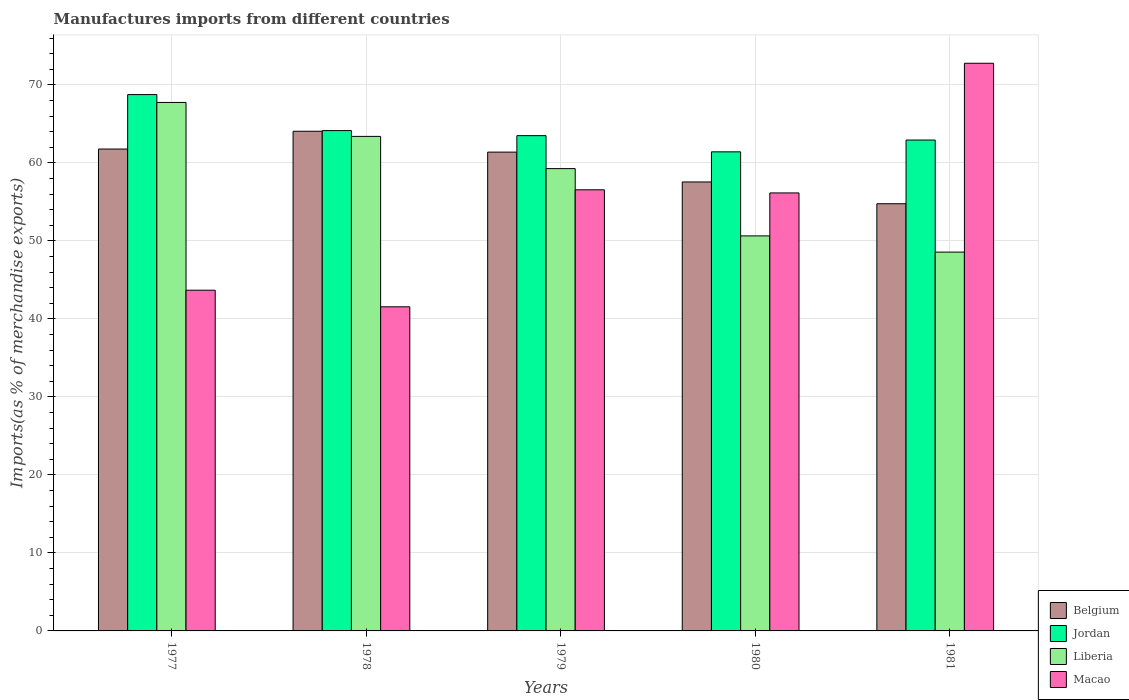How many different coloured bars are there?
Your answer should be very brief. 4. Are the number of bars per tick equal to the number of legend labels?
Your response must be concise. Yes. How many bars are there on the 4th tick from the left?
Your answer should be very brief. 4. What is the label of the 1st group of bars from the left?
Your answer should be very brief. 1977. In how many cases, is the number of bars for a given year not equal to the number of legend labels?
Offer a terse response. 0. What is the percentage of imports to different countries in Belgium in 1979?
Your answer should be compact. 61.39. Across all years, what is the maximum percentage of imports to different countries in Liberia?
Keep it short and to the point. 67.76. Across all years, what is the minimum percentage of imports to different countries in Belgium?
Give a very brief answer. 54.77. In which year was the percentage of imports to different countries in Belgium maximum?
Your answer should be very brief. 1978. In which year was the percentage of imports to different countries in Liberia minimum?
Ensure brevity in your answer.  1981. What is the total percentage of imports to different countries in Belgium in the graph?
Provide a succinct answer. 299.56. What is the difference between the percentage of imports to different countries in Belgium in 1977 and that in 1980?
Your response must be concise. 4.22. What is the difference between the percentage of imports to different countries in Liberia in 1981 and the percentage of imports to different countries in Jordan in 1978?
Give a very brief answer. -15.58. What is the average percentage of imports to different countries in Liberia per year?
Ensure brevity in your answer.  57.93. In the year 1978, what is the difference between the percentage of imports to different countries in Macao and percentage of imports to different countries in Belgium?
Give a very brief answer. -22.51. In how many years, is the percentage of imports to different countries in Jordan greater than 28 %?
Give a very brief answer. 5. What is the ratio of the percentage of imports to different countries in Macao in 1979 to that in 1980?
Your response must be concise. 1.01. Is the percentage of imports to different countries in Jordan in 1979 less than that in 1981?
Give a very brief answer. No. Is the difference between the percentage of imports to different countries in Macao in 1980 and 1981 greater than the difference between the percentage of imports to different countries in Belgium in 1980 and 1981?
Offer a very short reply. No. What is the difference between the highest and the second highest percentage of imports to different countries in Liberia?
Offer a very short reply. 4.35. What is the difference between the highest and the lowest percentage of imports to different countries in Belgium?
Give a very brief answer. 9.29. What does the 4th bar from the left in 1981 represents?
Your response must be concise. Macao. What does the 1st bar from the right in 1980 represents?
Provide a short and direct response. Macao. Is it the case that in every year, the sum of the percentage of imports to different countries in Macao and percentage of imports to different countries in Jordan is greater than the percentage of imports to different countries in Belgium?
Offer a very short reply. Yes. Are all the bars in the graph horizontal?
Provide a succinct answer. No. Does the graph contain grids?
Ensure brevity in your answer.  Yes. Where does the legend appear in the graph?
Offer a very short reply. Bottom right. How many legend labels are there?
Make the answer very short. 4. What is the title of the graph?
Ensure brevity in your answer.  Manufactures imports from different countries. What is the label or title of the Y-axis?
Give a very brief answer. Imports(as % of merchandise exports). What is the Imports(as % of merchandise exports) of Belgium in 1977?
Keep it short and to the point. 61.78. What is the Imports(as % of merchandise exports) of Jordan in 1977?
Provide a short and direct response. 68.76. What is the Imports(as % of merchandise exports) in Liberia in 1977?
Provide a succinct answer. 67.76. What is the Imports(as % of merchandise exports) of Macao in 1977?
Offer a very short reply. 43.68. What is the Imports(as % of merchandise exports) of Belgium in 1978?
Give a very brief answer. 64.06. What is the Imports(as % of merchandise exports) in Jordan in 1978?
Your answer should be compact. 64.15. What is the Imports(as % of merchandise exports) in Liberia in 1978?
Give a very brief answer. 63.4. What is the Imports(as % of merchandise exports) of Macao in 1978?
Make the answer very short. 41.56. What is the Imports(as % of merchandise exports) of Belgium in 1979?
Your answer should be compact. 61.39. What is the Imports(as % of merchandise exports) of Jordan in 1979?
Offer a very short reply. 63.5. What is the Imports(as % of merchandise exports) of Liberia in 1979?
Provide a short and direct response. 59.27. What is the Imports(as % of merchandise exports) of Macao in 1979?
Offer a very short reply. 56.56. What is the Imports(as % of merchandise exports) in Belgium in 1980?
Keep it short and to the point. 57.56. What is the Imports(as % of merchandise exports) of Jordan in 1980?
Ensure brevity in your answer.  61.42. What is the Imports(as % of merchandise exports) in Liberia in 1980?
Give a very brief answer. 50.65. What is the Imports(as % of merchandise exports) of Macao in 1980?
Your answer should be compact. 56.16. What is the Imports(as % of merchandise exports) of Belgium in 1981?
Ensure brevity in your answer.  54.77. What is the Imports(as % of merchandise exports) of Jordan in 1981?
Keep it short and to the point. 62.94. What is the Imports(as % of merchandise exports) in Liberia in 1981?
Provide a succinct answer. 48.57. What is the Imports(as % of merchandise exports) of Macao in 1981?
Provide a short and direct response. 72.78. Across all years, what is the maximum Imports(as % of merchandise exports) in Belgium?
Your answer should be very brief. 64.06. Across all years, what is the maximum Imports(as % of merchandise exports) in Jordan?
Your answer should be compact. 68.76. Across all years, what is the maximum Imports(as % of merchandise exports) of Liberia?
Offer a very short reply. 67.76. Across all years, what is the maximum Imports(as % of merchandise exports) in Macao?
Make the answer very short. 72.78. Across all years, what is the minimum Imports(as % of merchandise exports) in Belgium?
Your response must be concise. 54.77. Across all years, what is the minimum Imports(as % of merchandise exports) of Jordan?
Provide a succinct answer. 61.42. Across all years, what is the minimum Imports(as % of merchandise exports) of Liberia?
Keep it short and to the point. 48.57. Across all years, what is the minimum Imports(as % of merchandise exports) of Macao?
Your answer should be very brief. 41.56. What is the total Imports(as % of merchandise exports) of Belgium in the graph?
Keep it short and to the point. 299.56. What is the total Imports(as % of merchandise exports) of Jordan in the graph?
Offer a very short reply. 320.77. What is the total Imports(as % of merchandise exports) in Liberia in the graph?
Offer a very short reply. 289.64. What is the total Imports(as % of merchandise exports) of Macao in the graph?
Provide a short and direct response. 270.73. What is the difference between the Imports(as % of merchandise exports) of Belgium in 1977 and that in 1978?
Your answer should be compact. -2.28. What is the difference between the Imports(as % of merchandise exports) of Jordan in 1977 and that in 1978?
Offer a terse response. 4.62. What is the difference between the Imports(as % of merchandise exports) of Liberia in 1977 and that in 1978?
Make the answer very short. 4.35. What is the difference between the Imports(as % of merchandise exports) of Macao in 1977 and that in 1978?
Your answer should be very brief. 2.13. What is the difference between the Imports(as % of merchandise exports) in Belgium in 1977 and that in 1979?
Keep it short and to the point. 0.4. What is the difference between the Imports(as % of merchandise exports) of Jordan in 1977 and that in 1979?
Your answer should be compact. 5.26. What is the difference between the Imports(as % of merchandise exports) of Liberia in 1977 and that in 1979?
Your answer should be very brief. 8.48. What is the difference between the Imports(as % of merchandise exports) in Macao in 1977 and that in 1979?
Keep it short and to the point. -12.87. What is the difference between the Imports(as % of merchandise exports) of Belgium in 1977 and that in 1980?
Give a very brief answer. 4.22. What is the difference between the Imports(as % of merchandise exports) in Jordan in 1977 and that in 1980?
Offer a very short reply. 7.34. What is the difference between the Imports(as % of merchandise exports) of Liberia in 1977 and that in 1980?
Provide a short and direct response. 17.11. What is the difference between the Imports(as % of merchandise exports) of Macao in 1977 and that in 1980?
Make the answer very short. -12.47. What is the difference between the Imports(as % of merchandise exports) of Belgium in 1977 and that in 1981?
Your response must be concise. 7.02. What is the difference between the Imports(as % of merchandise exports) of Jordan in 1977 and that in 1981?
Make the answer very short. 5.83. What is the difference between the Imports(as % of merchandise exports) of Liberia in 1977 and that in 1981?
Your answer should be compact. 19.19. What is the difference between the Imports(as % of merchandise exports) of Macao in 1977 and that in 1981?
Your response must be concise. -29.1. What is the difference between the Imports(as % of merchandise exports) of Belgium in 1978 and that in 1979?
Offer a very short reply. 2.67. What is the difference between the Imports(as % of merchandise exports) in Jordan in 1978 and that in 1979?
Give a very brief answer. 0.65. What is the difference between the Imports(as % of merchandise exports) in Liberia in 1978 and that in 1979?
Give a very brief answer. 4.13. What is the difference between the Imports(as % of merchandise exports) in Macao in 1978 and that in 1979?
Offer a terse response. -15. What is the difference between the Imports(as % of merchandise exports) in Belgium in 1978 and that in 1980?
Provide a succinct answer. 6.5. What is the difference between the Imports(as % of merchandise exports) of Jordan in 1978 and that in 1980?
Provide a short and direct response. 2.72. What is the difference between the Imports(as % of merchandise exports) of Liberia in 1978 and that in 1980?
Keep it short and to the point. 12.76. What is the difference between the Imports(as % of merchandise exports) of Macao in 1978 and that in 1980?
Your response must be concise. -14.6. What is the difference between the Imports(as % of merchandise exports) of Belgium in 1978 and that in 1981?
Provide a short and direct response. 9.29. What is the difference between the Imports(as % of merchandise exports) of Jordan in 1978 and that in 1981?
Offer a terse response. 1.21. What is the difference between the Imports(as % of merchandise exports) of Liberia in 1978 and that in 1981?
Offer a very short reply. 14.83. What is the difference between the Imports(as % of merchandise exports) of Macao in 1978 and that in 1981?
Give a very brief answer. -31.23. What is the difference between the Imports(as % of merchandise exports) in Belgium in 1979 and that in 1980?
Make the answer very short. 3.83. What is the difference between the Imports(as % of merchandise exports) in Jordan in 1979 and that in 1980?
Ensure brevity in your answer.  2.08. What is the difference between the Imports(as % of merchandise exports) of Liberia in 1979 and that in 1980?
Ensure brevity in your answer.  8.63. What is the difference between the Imports(as % of merchandise exports) of Macao in 1979 and that in 1980?
Give a very brief answer. 0.4. What is the difference between the Imports(as % of merchandise exports) in Belgium in 1979 and that in 1981?
Your answer should be compact. 6.62. What is the difference between the Imports(as % of merchandise exports) in Jordan in 1979 and that in 1981?
Ensure brevity in your answer.  0.56. What is the difference between the Imports(as % of merchandise exports) of Liberia in 1979 and that in 1981?
Offer a terse response. 10.7. What is the difference between the Imports(as % of merchandise exports) of Macao in 1979 and that in 1981?
Give a very brief answer. -16.22. What is the difference between the Imports(as % of merchandise exports) in Belgium in 1980 and that in 1981?
Keep it short and to the point. 2.79. What is the difference between the Imports(as % of merchandise exports) of Jordan in 1980 and that in 1981?
Give a very brief answer. -1.51. What is the difference between the Imports(as % of merchandise exports) in Liberia in 1980 and that in 1981?
Your answer should be compact. 2.08. What is the difference between the Imports(as % of merchandise exports) in Macao in 1980 and that in 1981?
Your response must be concise. -16.62. What is the difference between the Imports(as % of merchandise exports) in Belgium in 1977 and the Imports(as % of merchandise exports) in Jordan in 1978?
Your response must be concise. -2.36. What is the difference between the Imports(as % of merchandise exports) in Belgium in 1977 and the Imports(as % of merchandise exports) in Liberia in 1978?
Ensure brevity in your answer.  -1.62. What is the difference between the Imports(as % of merchandise exports) in Belgium in 1977 and the Imports(as % of merchandise exports) in Macao in 1978?
Make the answer very short. 20.23. What is the difference between the Imports(as % of merchandise exports) in Jordan in 1977 and the Imports(as % of merchandise exports) in Liberia in 1978?
Your response must be concise. 5.36. What is the difference between the Imports(as % of merchandise exports) of Jordan in 1977 and the Imports(as % of merchandise exports) of Macao in 1978?
Offer a terse response. 27.21. What is the difference between the Imports(as % of merchandise exports) in Liberia in 1977 and the Imports(as % of merchandise exports) in Macao in 1978?
Your answer should be very brief. 26.2. What is the difference between the Imports(as % of merchandise exports) of Belgium in 1977 and the Imports(as % of merchandise exports) of Jordan in 1979?
Make the answer very short. -1.72. What is the difference between the Imports(as % of merchandise exports) in Belgium in 1977 and the Imports(as % of merchandise exports) in Liberia in 1979?
Ensure brevity in your answer.  2.51. What is the difference between the Imports(as % of merchandise exports) of Belgium in 1977 and the Imports(as % of merchandise exports) of Macao in 1979?
Give a very brief answer. 5.23. What is the difference between the Imports(as % of merchandise exports) of Jordan in 1977 and the Imports(as % of merchandise exports) of Liberia in 1979?
Your response must be concise. 9.49. What is the difference between the Imports(as % of merchandise exports) in Jordan in 1977 and the Imports(as % of merchandise exports) in Macao in 1979?
Your answer should be very brief. 12.21. What is the difference between the Imports(as % of merchandise exports) in Liberia in 1977 and the Imports(as % of merchandise exports) in Macao in 1979?
Your response must be concise. 11.2. What is the difference between the Imports(as % of merchandise exports) in Belgium in 1977 and the Imports(as % of merchandise exports) in Jordan in 1980?
Keep it short and to the point. 0.36. What is the difference between the Imports(as % of merchandise exports) of Belgium in 1977 and the Imports(as % of merchandise exports) of Liberia in 1980?
Your answer should be very brief. 11.14. What is the difference between the Imports(as % of merchandise exports) of Belgium in 1977 and the Imports(as % of merchandise exports) of Macao in 1980?
Offer a terse response. 5.63. What is the difference between the Imports(as % of merchandise exports) in Jordan in 1977 and the Imports(as % of merchandise exports) in Liberia in 1980?
Your response must be concise. 18.12. What is the difference between the Imports(as % of merchandise exports) of Jordan in 1977 and the Imports(as % of merchandise exports) of Macao in 1980?
Your answer should be very brief. 12.61. What is the difference between the Imports(as % of merchandise exports) of Liberia in 1977 and the Imports(as % of merchandise exports) of Macao in 1980?
Your answer should be compact. 11.6. What is the difference between the Imports(as % of merchandise exports) in Belgium in 1977 and the Imports(as % of merchandise exports) in Jordan in 1981?
Make the answer very short. -1.15. What is the difference between the Imports(as % of merchandise exports) of Belgium in 1977 and the Imports(as % of merchandise exports) of Liberia in 1981?
Your answer should be compact. 13.21. What is the difference between the Imports(as % of merchandise exports) of Belgium in 1977 and the Imports(as % of merchandise exports) of Macao in 1981?
Your answer should be very brief. -11. What is the difference between the Imports(as % of merchandise exports) in Jordan in 1977 and the Imports(as % of merchandise exports) in Liberia in 1981?
Offer a terse response. 20.2. What is the difference between the Imports(as % of merchandise exports) of Jordan in 1977 and the Imports(as % of merchandise exports) of Macao in 1981?
Keep it short and to the point. -4.02. What is the difference between the Imports(as % of merchandise exports) of Liberia in 1977 and the Imports(as % of merchandise exports) of Macao in 1981?
Your answer should be compact. -5.03. What is the difference between the Imports(as % of merchandise exports) in Belgium in 1978 and the Imports(as % of merchandise exports) in Jordan in 1979?
Your answer should be very brief. 0.56. What is the difference between the Imports(as % of merchandise exports) in Belgium in 1978 and the Imports(as % of merchandise exports) in Liberia in 1979?
Your answer should be compact. 4.79. What is the difference between the Imports(as % of merchandise exports) of Belgium in 1978 and the Imports(as % of merchandise exports) of Macao in 1979?
Ensure brevity in your answer.  7.51. What is the difference between the Imports(as % of merchandise exports) of Jordan in 1978 and the Imports(as % of merchandise exports) of Liberia in 1979?
Make the answer very short. 4.87. What is the difference between the Imports(as % of merchandise exports) of Jordan in 1978 and the Imports(as % of merchandise exports) of Macao in 1979?
Ensure brevity in your answer.  7.59. What is the difference between the Imports(as % of merchandise exports) of Liberia in 1978 and the Imports(as % of merchandise exports) of Macao in 1979?
Make the answer very short. 6.85. What is the difference between the Imports(as % of merchandise exports) of Belgium in 1978 and the Imports(as % of merchandise exports) of Jordan in 1980?
Your answer should be very brief. 2.64. What is the difference between the Imports(as % of merchandise exports) of Belgium in 1978 and the Imports(as % of merchandise exports) of Liberia in 1980?
Offer a terse response. 13.42. What is the difference between the Imports(as % of merchandise exports) in Belgium in 1978 and the Imports(as % of merchandise exports) in Macao in 1980?
Offer a very short reply. 7.91. What is the difference between the Imports(as % of merchandise exports) in Jordan in 1978 and the Imports(as % of merchandise exports) in Liberia in 1980?
Offer a terse response. 13.5. What is the difference between the Imports(as % of merchandise exports) of Jordan in 1978 and the Imports(as % of merchandise exports) of Macao in 1980?
Offer a terse response. 7.99. What is the difference between the Imports(as % of merchandise exports) in Liberia in 1978 and the Imports(as % of merchandise exports) in Macao in 1980?
Offer a terse response. 7.25. What is the difference between the Imports(as % of merchandise exports) in Belgium in 1978 and the Imports(as % of merchandise exports) in Jordan in 1981?
Provide a succinct answer. 1.12. What is the difference between the Imports(as % of merchandise exports) of Belgium in 1978 and the Imports(as % of merchandise exports) of Liberia in 1981?
Keep it short and to the point. 15.49. What is the difference between the Imports(as % of merchandise exports) in Belgium in 1978 and the Imports(as % of merchandise exports) in Macao in 1981?
Give a very brief answer. -8.72. What is the difference between the Imports(as % of merchandise exports) of Jordan in 1978 and the Imports(as % of merchandise exports) of Liberia in 1981?
Provide a succinct answer. 15.58. What is the difference between the Imports(as % of merchandise exports) of Jordan in 1978 and the Imports(as % of merchandise exports) of Macao in 1981?
Your response must be concise. -8.63. What is the difference between the Imports(as % of merchandise exports) of Liberia in 1978 and the Imports(as % of merchandise exports) of Macao in 1981?
Your answer should be compact. -9.38. What is the difference between the Imports(as % of merchandise exports) in Belgium in 1979 and the Imports(as % of merchandise exports) in Jordan in 1980?
Keep it short and to the point. -0.04. What is the difference between the Imports(as % of merchandise exports) of Belgium in 1979 and the Imports(as % of merchandise exports) of Liberia in 1980?
Provide a succinct answer. 10.74. What is the difference between the Imports(as % of merchandise exports) of Belgium in 1979 and the Imports(as % of merchandise exports) of Macao in 1980?
Provide a succinct answer. 5.23. What is the difference between the Imports(as % of merchandise exports) in Jordan in 1979 and the Imports(as % of merchandise exports) in Liberia in 1980?
Offer a terse response. 12.85. What is the difference between the Imports(as % of merchandise exports) of Jordan in 1979 and the Imports(as % of merchandise exports) of Macao in 1980?
Provide a succinct answer. 7.34. What is the difference between the Imports(as % of merchandise exports) in Liberia in 1979 and the Imports(as % of merchandise exports) in Macao in 1980?
Provide a short and direct response. 3.12. What is the difference between the Imports(as % of merchandise exports) in Belgium in 1979 and the Imports(as % of merchandise exports) in Jordan in 1981?
Offer a terse response. -1.55. What is the difference between the Imports(as % of merchandise exports) in Belgium in 1979 and the Imports(as % of merchandise exports) in Liberia in 1981?
Your answer should be very brief. 12.82. What is the difference between the Imports(as % of merchandise exports) of Belgium in 1979 and the Imports(as % of merchandise exports) of Macao in 1981?
Offer a terse response. -11.39. What is the difference between the Imports(as % of merchandise exports) in Jordan in 1979 and the Imports(as % of merchandise exports) in Liberia in 1981?
Your answer should be very brief. 14.93. What is the difference between the Imports(as % of merchandise exports) in Jordan in 1979 and the Imports(as % of merchandise exports) in Macao in 1981?
Make the answer very short. -9.28. What is the difference between the Imports(as % of merchandise exports) of Liberia in 1979 and the Imports(as % of merchandise exports) of Macao in 1981?
Offer a very short reply. -13.51. What is the difference between the Imports(as % of merchandise exports) in Belgium in 1980 and the Imports(as % of merchandise exports) in Jordan in 1981?
Provide a short and direct response. -5.38. What is the difference between the Imports(as % of merchandise exports) in Belgium in 1980 and the Imports(as % of merchandise exports) in Liberia in 1981?
Make the answer very short. 8.99. What is the difference between the Imports(as % of merchandise exports) of Belgium in 1980 and the Imports(as % of merchandise exports) of Macao in 1981?
Ensure brevity in your answer.  -15.22. What is the difference between the Imports(as % of merchandise exports) in Jordan in 1980 and the Imports(as % of merchandise exports) in Liberia in 1981?
Provide a succinct answer. 12.85. What is the difference between the Imports(as % of merchandise exports) of Jordan in 1980 and the Imports(as % of merchandise exports) of Macao in 1981?
Give a very brief answer. -11.36. What is the difference between the Imports(as % of merchandise exports) in Liberia in 1980 and the Imports(as % of merchandise exports) in Macao in 1981?
Provide a succinct answer. -22.13. What is the average Imports(as % of merchandise exports) of Belgium per year?
Your response must be concise. 59.91. What is the average Imports(as % of merchandise exports) of Jordan per year?
Give a very brief answer. 64.15. What is the average Imports(as % of merchandise exports) of Liberia per year?
Give a very brief answer. 57.93. What is the average Imports(as % of merchandise exports) in Macao per year?
Make the answer very short. 54.15. In the year 1977, what is the difference between the Imports(as % of merchandise exports) of Belgium and Imports(as % of merchandise exports) of Jordan?
Keep it short and to the point. -6.98. In the year 1977, what is the difference between the Imports(as % of merchandise exports) in Belgium and Imports(as % of merchandise exports) in Liberia?
Keep it short and to the point. -5.97. In the year 1977, what is the difference between the Imports(as % of merchandise exports) of Belgium and Imports(as % of merchandise exports) of Macao?
Your answer should be very brief. 18.1. In the year 1977, what is the difference between the Imports(as % of merchandise exports) of Jordan and Imports(as % of merchandise exports) of Liberia?
Provide a short and direct response. 1.01. In the year 1977, what is the difference between the Imports(as % of merchandise exports) of Jordan and Imports(as % of merchandise exports) of Macao?
Your response must be concise. 25.08. In the year 1977, what is the difference between the Imports(as % of merchandise exports) of Liberia and Imports(as % of merchandise exports) of Macao?
Your response must be concise. 24.07. In the year 1978, what is the difference between the Imports(as % of merchandise exports) of Belgium and Imports(as % of merchandise exports) of Jordan?
Offer a terse response. -0.09. In the year 1978, what is the difference between the Imports(as % of merchandise exports) in Belgium and Imports(as % of merchandise exports) in Liberia?
Give a very brief answer. 0.66. In the year 1978, what is the difference between the Imports(as % of merchandise exports) in Belgium and Imports(as % of merchandise exports) in Macao?
Your answer should be compact. 22.51. In the year 1978, what is the difference between the Imports(as % of merchandise exports) of Jordan and Imports(as % of merchandise exports) of Liberia?
Provide a succinct answer. 0.74. In the year 1978, what is the difference between the Imports(as % of merchandise exports) in Jordan and Imports(as % of merchandise exports) in Macao?
Ensure brevity in your answer.  22.59. In the year 1978, what is the difference between the Imports(as % of merchandise exports) in Liberia and Imports(as % of merchandise exports) in Macao?
Keep it short and to the point. 21.85. In the year 1979, what is the difference between the Imports(as % of merchandise exports) of Belgium and Imports(as % of merchandise exports) of Jordan?
Make the answer very short. -2.11. In the year 1979, what is the difference between the Imports(as % of merchandise exports) of Belgium and Imports(as % of merchandise exports) of Liberia?
Ensure brevity in your answer.  2.12. In the year 1979, what is the difference between the Imports(as % of merchandise exports) in Belgium and Imports(as % of merchandise exports) in Macao?
Your response must be concise. 4.83. In the year 1979, what is the difference between the Imports(as % of merchandise exports) in Jordan and Imports(as % of merchandise exports) in Liberia?
Keep it short and to the point. 4.23. In the year 1979, what is the difference between the Imports(as % of merchandise exports) of Jordan and Imports(as % of merchandise exports) of Macao?
Make the answer very short. 6.94. In the year 1979, what is the difference between the Imports(as % of merchandise exports) of Liberia and Imports(as % of merchandise exports) of Macao?
Offer a terse response. 2.72. In the year 1980, what is the difference between the Imports(as % of merchandise exports) in Belgium and Imports(as % of merchandise exports) in Jordan?
Give a very brief answer. -3.86. In the year 1980, what is the difference between the Imports(as % of merchandise exports) of Belgium and Imports(as % of merchandise exports) of Liberia?
Your answer should be compact. 6.92. In the year 1980, what is the difference between the Imports(as % of merchandise exports) of Belgium and Imports(as % of merchandise exports) of Macao?
Make the answer very short. 1.41. In the year 1980, what is the difference between the Imports(as % of merchandise exports) in Jordan and Imports(as % of merchandise exports) in Liberia?
Provide a succinct answer. 10.78. In the year 1980, what is the difference between the Imports(as % of merchandise exports) in Jordan and Imports(as % of merchandise exports) in Macao?
Your response must be concise. 5.27. In the year 1980, what is the difference between the Imports(as % of merchandise exports) of Liberia and Imports(as % of merchandise exports) of Macao?
Provide a succinct answer. -5.51. In the year 1981, what is the difference between the Imports(as % of merchandise exports) in Belgium and Imports(as % of merchandise exports) in Jordan?
Your response must be concise. -8.17. In the year 1981, what is the difference between the Imports(as % of merchandise exports) in Belgium and Imports(as % of merchandise exports) in Liberia?
Ensure brevity in your answer.  6.2. In the year 1981, what is the difference between the Imports(as % of merchandise exports) of Belgium and Imports(as % of merchandise exports) of Macao?
Your response must be concise. -18.01. In the year 1981, what is the difference between the Imports(as % of merchandise exports) in Jordan and Imports(as % of merchandise exports) in Liberia?
Offer a very short reply. 14.37. In the year 1981, what is the difference between the Imports(as % of merchandise exports) of Jordan and Imports(as % of merchandise exports) of Macao?
Offer a terse response. -9.84. In the year 1981, what is the difference between the Imports(as % of merchandise exports) in Liberia and Imports(as % of merchandise exports) in Macao?
Give a very brief answer. -24.21. What is the ratio of the Imports(as % of merchandise exports) of Belgium in 1977 to that in 1978?
Keep it short and to the point. 0.96. What is the ratio of the Imports(as % of merchandise exports) in Jordan in 1977 to that in 1978?
Offer a very short reply. 1.07. What is the ratio of the Imports(as % of merchandise exports) in Liberia in 1977 to that in 1978?
Your answer should be compact. 1.07. What is the ratio of the Imports(as % of merchandise exports) of Macao in 1977 to that in 1978?
Provide a short and direct response. 1.05. What is the ratio of the Imports(as % of merchandise exports) in Belgium in 1977 to that in 1979?
Make the answer very short. 1.01. What is the ratio of the Imports(as % of merchandise exports) in Jordan in 1977 to that in 1979?
Offer a very short reply. 1.08. What is the ratio of the Imports(as % of merchandise exports) of Liberia in 1977 to that in 1979?
Give a very brief answer. 1.14. What is the ratio of the Imports(as % of merchandise exports) in Macao in 1977 to that in 1979?
Your answer should be compact. 0.77. What is the ratio of the Imports(as % of merchandise exports) in Belgium in 1977 to that in 1980?
Ensure brevity in your answer.  1.07. What is the ratio of the Imports(as % of merchandise exports) of Jordan in 1977 to that in 1980?
Make the answer very short. 1.12. What is the ratio of the Imports(as % of merchandise exports) in Liberia in 1977 to that in 1980?
Offer a very short reply. 1.34. What is the ratio of the Imports(as % of merchandise exports) of Macao in 1977 to that in 1980?
Offer a very short reply. 0.78. What is the ratio of the Imports(as % of merchandise exports) in Belgium in 1977 to that in 1981?
Your response must be concise. 1.13. What is the ratio of the Imports(as % of merchandise exports) in Jordan in 1977 to that in 1981?
Offer a very short reply. 1.09. What is the ratio of the Imports(as % of merchandise exports) of Liberia in 1977 to that in 1981?
Keep it short and to the point. 1.4. What is the ratio of the Imports(as % of merchandise exports) in Macao in 1977 to that in 1981?
Keep it short and to the point. 0.6. What is the ratio of the Imports(as % of merchandise exports) in Belgium in 1978 to that in 1979?
Keep it short and to the point. 1.04. What is the ratio of the Imports(as % of merchandise exports) in Jordan in 1978 to that in 1979?
Give a very brief answer. 1.01. What is the ratio of the Imports(as % of merchandise exports) of Liberia in 1978 to that in 1979?
Give a very brief answer. 1.07. What is the ratio of the Imports(as % of merchandise exports) of Macao in 1978 to that in 1979?
Give a very brief answer. 0.73. What is the ratio of the Imports(as % of merchandise exports) in Belgium in 1978 to that in 1980?
Offer a very short reply. 1.11. What is the ratio of the Imports(as % of merchandise exports) of Jordan in 1978 to that in 1980?
Offer a terse response. 1.04. What is the ratio of the Imports(as % of merchandise exports) of Liberia in 1978 to that in 1980?
Offer a very short reply. 1.25. What is the ratio of the Imports(as % of merchandise exports) in Macao in 1978 to that in 1980?
Your answer should be very brief. 0.74. What is the ratio of the Imports(as % of merchandise exports) in Belgium in 1978 to that in 1981?
Make the answer very short. 1.17. What is the ratio of the Imports(as % of merchandise exports) of Jordan in 1978 to that in 1981?
Offer a very short reply. 1.02. What is the ratio of the Imports(as % of merchandise exports) in Liberia in 1978 to that in 1981?
Provide a succinct answer. 1.31. What is the ratio of the Imports(as % of merchandise exports) of Macao in 1978 to that in 1981?
Keep it short and to the point. 0.57. What is the ratio of the Imports(as % of merchandise exports) of Belgium in 1979 to that in 1980?
Offer a very short reply. 1.07. What is the ratio of the Imports(as % of merchandise exports) of Jordan in 1979 to that in 1980?
Your response must be concise. 1.03. What is the ratio of the Imports(as % of merchandise exports) in Liberia in 1979 to that in 1980?
Make the answer very short. 1.17. What is the ratio of the Imports(as % of merchandise exports) in Macao in 1979 to that in 1980?
Give a very brief answer. 1.01. What is the ratio of the Imports(as % of merchandise exports) of Belgium in 1979 to that in 1981?
Your answer should be compact. 1.12. What is the ratio of the Imports(as % of merchandise exports) of Jordan in 1979 to that in 1981?
Offer a terse response. 1.01. What is the ratio of the Imports(as % of merchandise exports) in Liberia in 1979 to that in 1981?
Ensure brevity in your answer.  1.22. What is the ratio of the Imports(as % of merchandise exports) in Macao in 1979 to that in 1981?
Offer a terse response. 0.78. What is the ratio of the Imports(as % of merchandise exports) of Belgium in 1980 to that in 1981?
Your answer should be compact. 1.05. What is the ratio of the Imports(as % of merchandise exports) of Jordan in 1980 to that in 1981?
Your answer should be very brief. 0.98. What is the ratio of the Imports(as % of merchandise exports) in Liberia in 1980 to that in 1981?
Your answer should be compact. 1.04. What is the ratio of the Imports(as % of merchandise exports) in Macao in 1980 to that in 1981?
Give a very brief answer. 0.77. What is the difference between the highest and the second highest Imports(as % of merchandise exports) in Belgium?
Your answer should be very brief. 2.28. What is the difference between the highest and the second highest Imports(as % of merchandise exports) in Jordan?
Make the answer very short. 4.62. What is the difference between the highest and the second highest Imports(as % of merchandise exports) in Liberia?
Offer a very short reply. 4.35. What is the difference between the highest and the second highest Imports(as % of merchandise exports) of Macao?
Your answer should be very brief. 16.22. What is the difference between the highest and the lowest Imports(as % of merchandise exports) in Belgium?
Your response must be concise. 9.29. What is the difference between the highest and the lowest Imports(as % of merchandise exports) in Jordan?
Provide a short and direct response. 7.34. What is the difference between the highest and the lowest Imports(as % of merchandise exports) in Liberia?
Offer a very short reply. 19.19. What is the difference between the highest and the lowest Imports(as % of merchandise exports) in Macao?
Offer a very short reply. 31.23. 